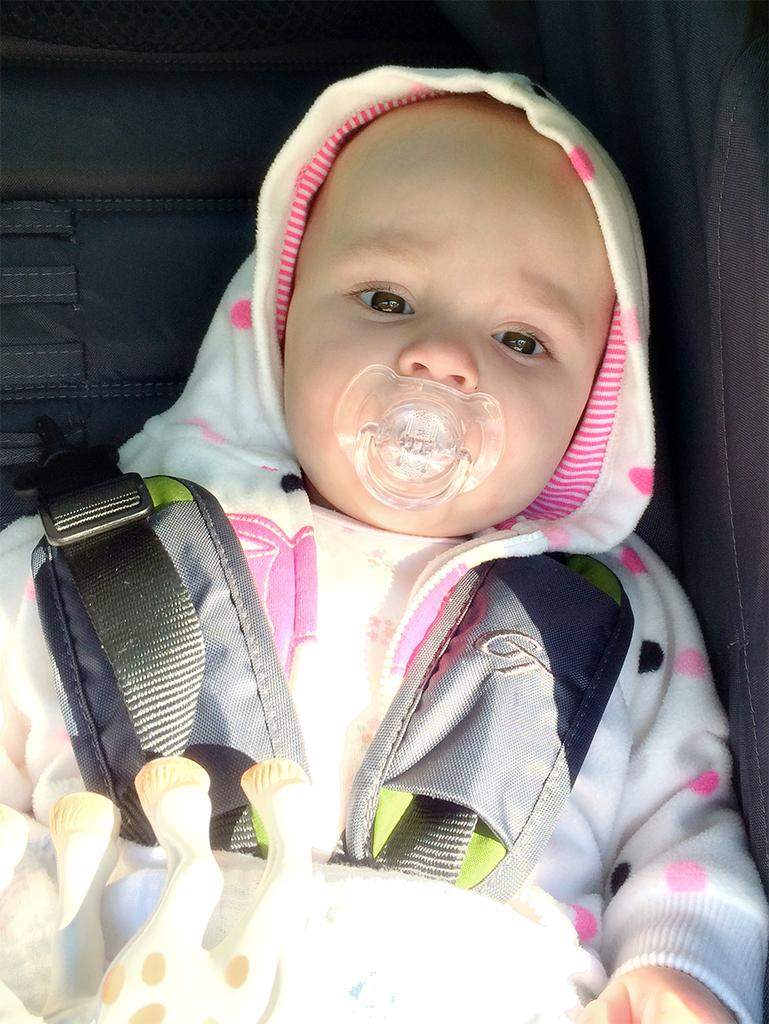What is the main subject of the image? There is a baby in the image. Can you describe the baby's clothing? The baby is wearing a white and pink dress. What is the baby holding or using in the image? The baby has a pacifier in his mouth. Are there any other objects or toys visible in the image? Yes, there is a toy in the image. What type of cup can be seen in the baby's hand in the image? There is no cup visible in the baby's hand in the image. Is the sun shining brightly in the background of the image? The provided facts do not mention the sun or any background elements, so we cannot determine if the sun is shining in the image. 